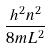Convert formula to latex. <formula><loc_0><loc_0><loc_500><loc_500>\frac { h ^ { 2 } n ^ { 2 } } { 8 m L ^ { 2 } }</formula> 